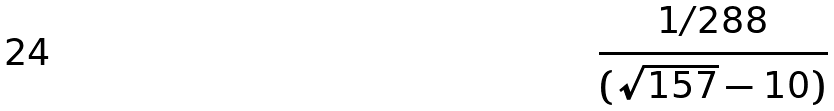<formula> <loc_0><loc_0><loc_500><loc_500>\frac { 1 / 2 8 8 } { ( \sqrt { 1 5 7 } - 1 0 ) }</formula> 